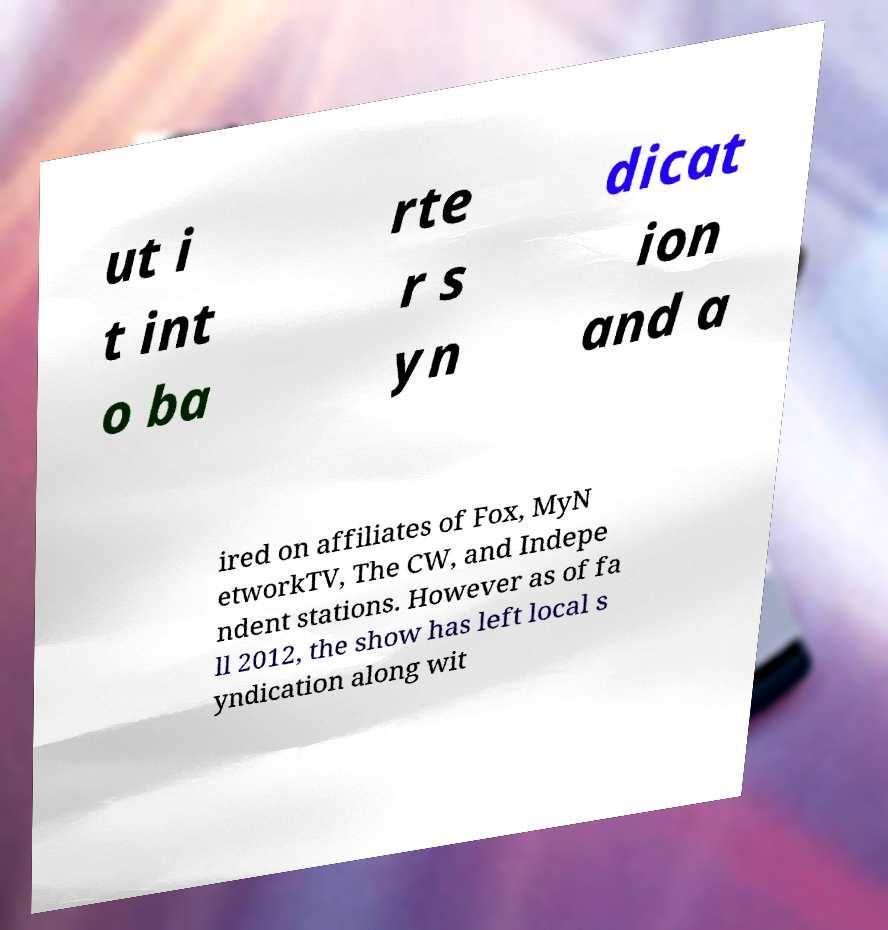Could you assist in decoding the text presented in this image and type it out clearly? ut i t int o ba rte r s yn dicat ion and a ired on affiliates of Fox, MyN etworkTV, The CW, and Indepe ndent stations. However as of fa ll 2012, the show has left local s yndication along wit 